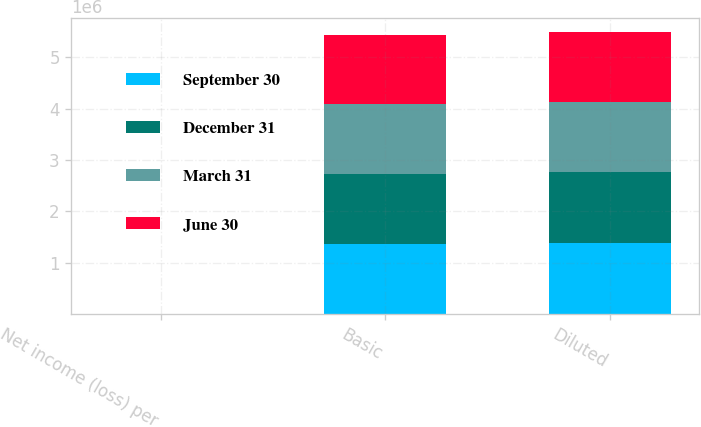Convert chart to OTSL. <chart><loc_0><loc_0><loc_500><loc_500><stacked_bar_chart><ecel><fcel>Net income (loss) per<fcel>Basic<fcel>Diluted<nl><fcel>September 30<fcel>0.27<fcel>1.36692e+06<fcel>1.38429e+06<nl><fcel>December 31<fcel>0.27<fcel>1.36105e+06<fcel>1.3787e+06<nl><fcel>March 31<fcel>0.69<fcel>1.35479e+06<fcel>1.35479e+06<nl><fcel>June 30<fcel>0.39<fcel>1.35208e+06<fcel>1.36807e+06<nl></chart> 